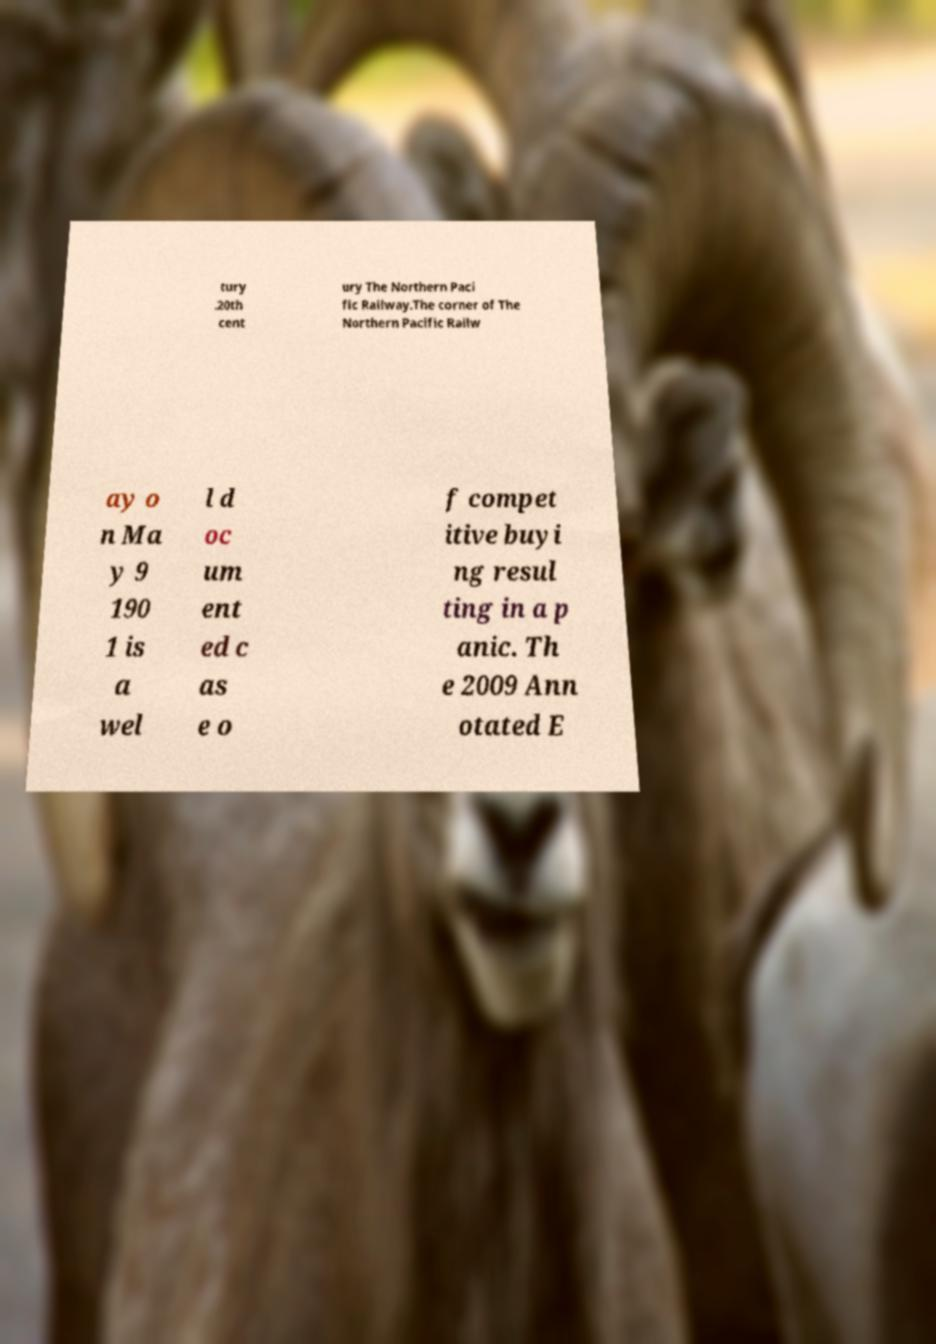Could you extract and type out the text from this image? tury .20th cent ury The Northern Paci fic Railway.The corner of The Northern Pacific Railw ay o n Ma y 9 190 1 is a wel l d oc um ent ed c as e o f compet itive buyi ng resul ting in a p anic. Th e 2009 Ann otated E 